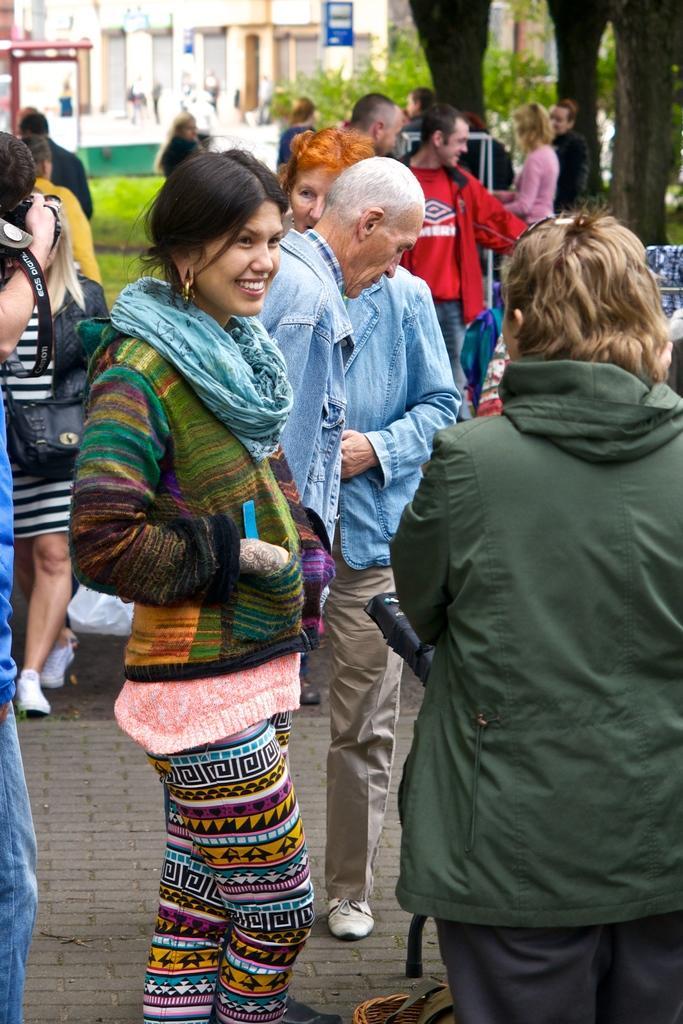How would you summarize this image in a sentence or two? In this image there are a group of people who are standing and in the background there are some buildings trees and some persons are walking and also there are some objects, at the bottom there is a walkway. 